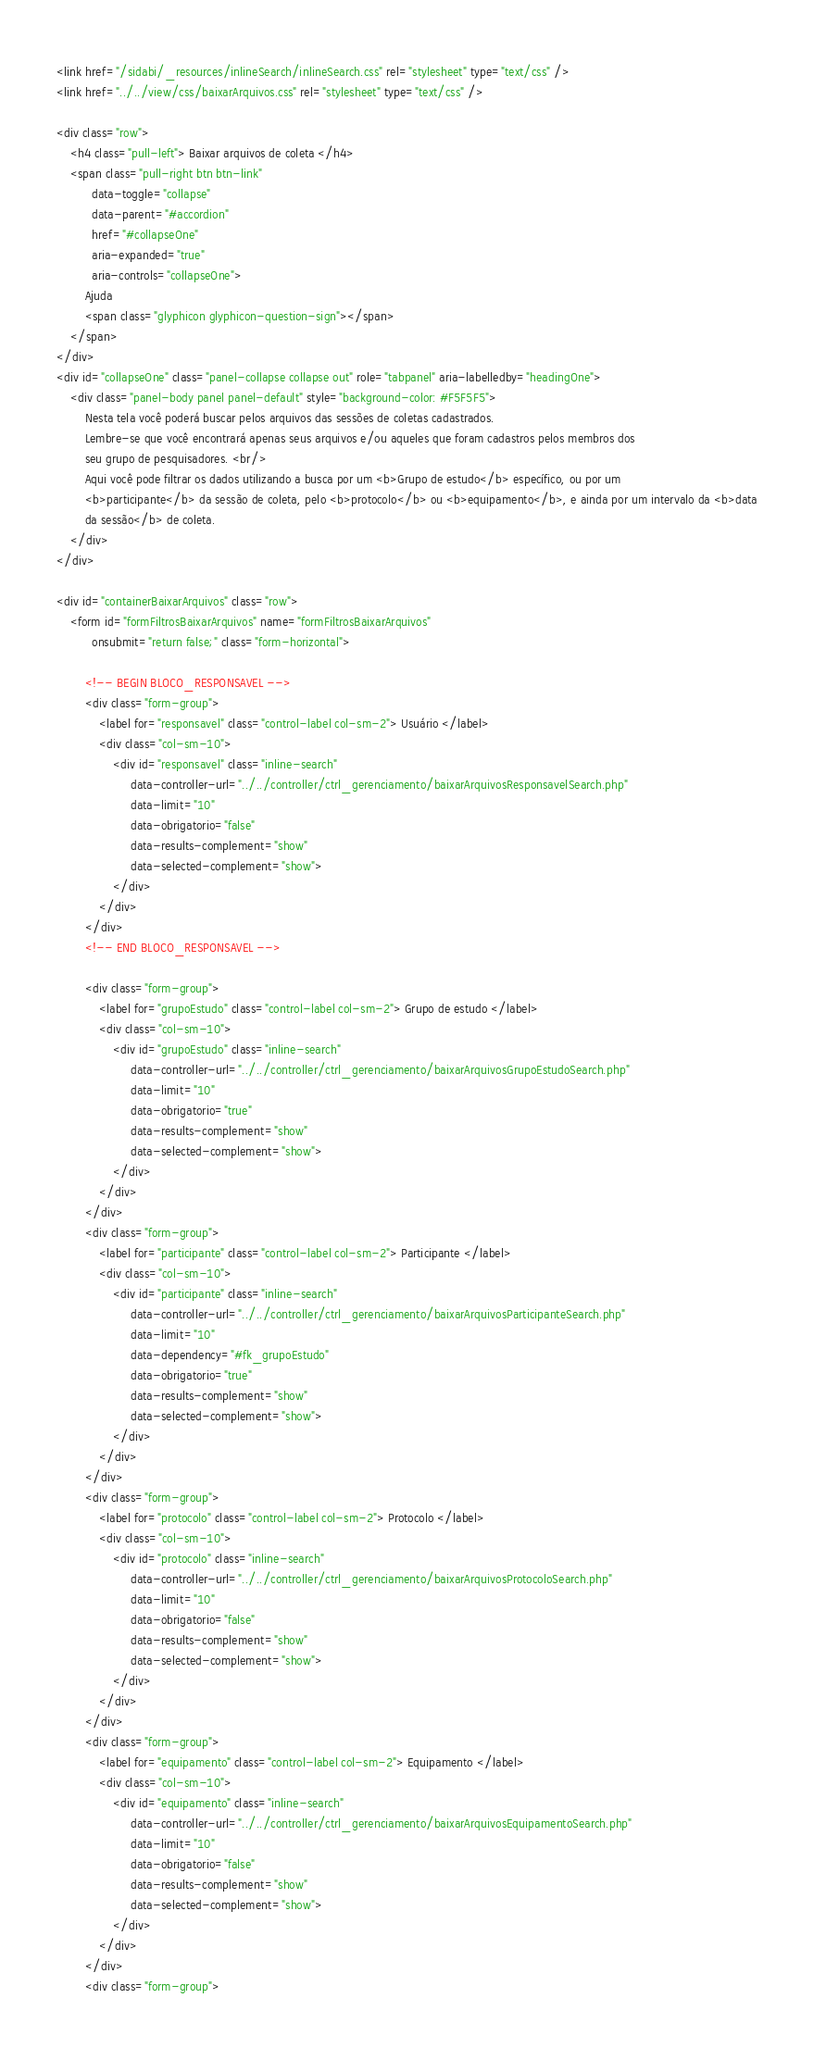<code> <loc_0><loc_0><loc_500><loc_500><_HTML_>
<link href="/sidabi/_resources/inlineSearch/inlineSearch.css" rel="stylesheet" type="text/css" />
<link href="../../view/css/baixarArquivos.css" rel="stylesheet" type="text/css" />

<div class="row">
    <h4 class="pull-left"> Baixar arquivos de coleta </h4>
    <span class="pull-right btn btn-link"
          data-toggle="collapse"
          data-parent="#accordion"
          href="#collapseOne"
          aria-expanded="true"
          aria-controls="collapseOne">
        Ajuda
        <span class="glyphicon glyphicon-question-sign"></span>
    </span>
</div>
<div id="collapseOne" class="panel-collapse collapse out" role="tabpanel" aria-labelledby="headingOne">
    <div class="panel-body panel panel-default" style="background-color: #F5F5F5">
        Nesta tela você poderá buscar pelos arquivos das sessões de coletas cadastrados.
        Lembre-se que você encontrará apenas seus arquivos e/ou aqueles que foram cadastros pelos membros dos
        seu grupo de pesquisadores. <br/>
        Aqui você pode filtrar os dados utilizando a busca por um <b>Grupo de estudo</b> específico, ou por um
        <b>participante</b> da sessão de coleta, pelo <b>protocolo</b> ou <b>equipamento</b>, e ainda por um intervalo da <b>data
        da sessão</b> de coleta.
    </div>
</div>

<div id="containerBaixarArquivos" class="row">
    <form id="formFiltrosBaixarArquivos" name="formFiltrosBaixarArquivos"
          onsubmit="return false;" class="form-horizontal">

        <!-- BEGIN BLOCO_RESPONSAVEL -->
        <div class="form-group">
            <label for="responsavel" class="control-label col-sm-2"> Usuário </label>
            <div class="col-sm-10">
                <div id="responsavel" class="inline-search"
                     data-controller-url="../../controller/ctrl_gerenciamento/baixarArquivosResponsavelSearch.php"
                     data-limit="10"
                     data-obrigatorio="false"
                     data-results-complement="show"
                     data-selected-complement="show">
                </div>
            </div>
        </div>
        <!-- END BLOCO_RESPONSAVEL -->

        <div class="form-group">
            <label for="grupoEstudo" class="control-label col-sm-2"> Grupo de estudo </label>
            <div class="col-sm-10">
                <div id="grupoEstudo" class="inline-search"
                     data-controller-url="../../controller/ctrl_gerenciamento/baixarArquivosGrupoEstudoSearch.php"
                     data-limit="10"
                     data-obrigatorio="true"
                     data-results-complement="show"
                     data-selected-complement="show">
                </div>
            </div>
        </div>
        <div class="form-group">
            <label for="participante" class="control-label col-sm-2"> Participante </label>
            <div class="col-sm-10">
                <div id="participante" class="inline-search"
                     data-controller-url="../../controller/ctrl_gerenciamento/baixarArquivosParticipanteSearch.php"
                     data-limit="10"
                     data-dependency="#fk_grupoEstudo"
                     data-obrigatorio="true"
                     data-results-complement="show"
                     data-selected-complement="show">
                </div>
            </div>
        </div>
        <div class="form-group">
            <label for="protocolo" class="control-label col-sm-2"> Protocolo </label>
            <div class="col-sm-10">
                <div id="protocolo" class="inline-search"
                     data-controller-url="../../controller/ctrl_gerenciamento/baixarArquivosProtocoloSearch.php"
                     data-limit="10"
                     data-obrigatorio="false"
                     data-results-complement="show"
                     data-selected-complement="show">
                </div>
            </div>
        </div>
        <div class="form-group">
            <label for="equipamento" class="control-label col-sm-2"> Equipamento </label>
            <div class="col-sm-10">
                <div id="equipamento" class="inline-search"
                     data-controller-url="../../controller/ctrl_gerenciamento/baixarArquivosEquipamentoSearch.php"
                     data-limit="10"
                     data-obrigatorio="false"
                     data-results-complement="show"
                     data-selected-complement="show">
                </div>
            </div>
        </div>
        <div class="form-group"></code> 